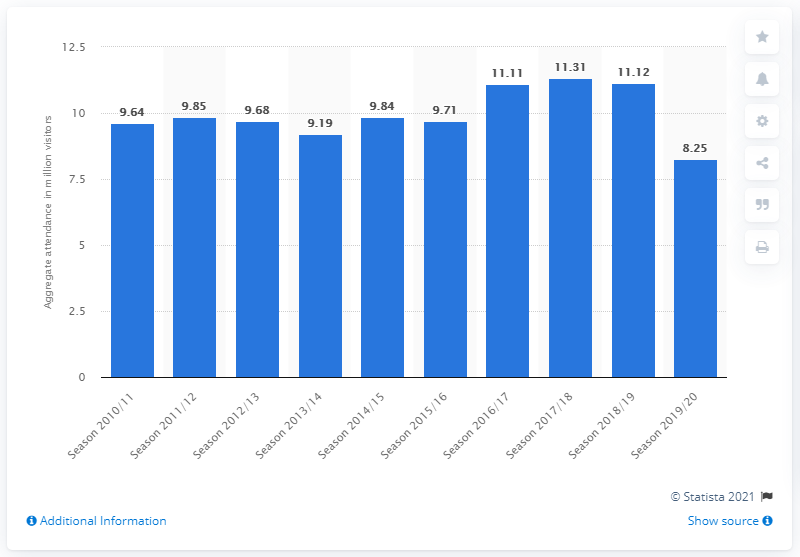Mention a couple of crucial points in this snapshot. In the 2019/2020 football league championship season, a total of 8.25 people attended. 